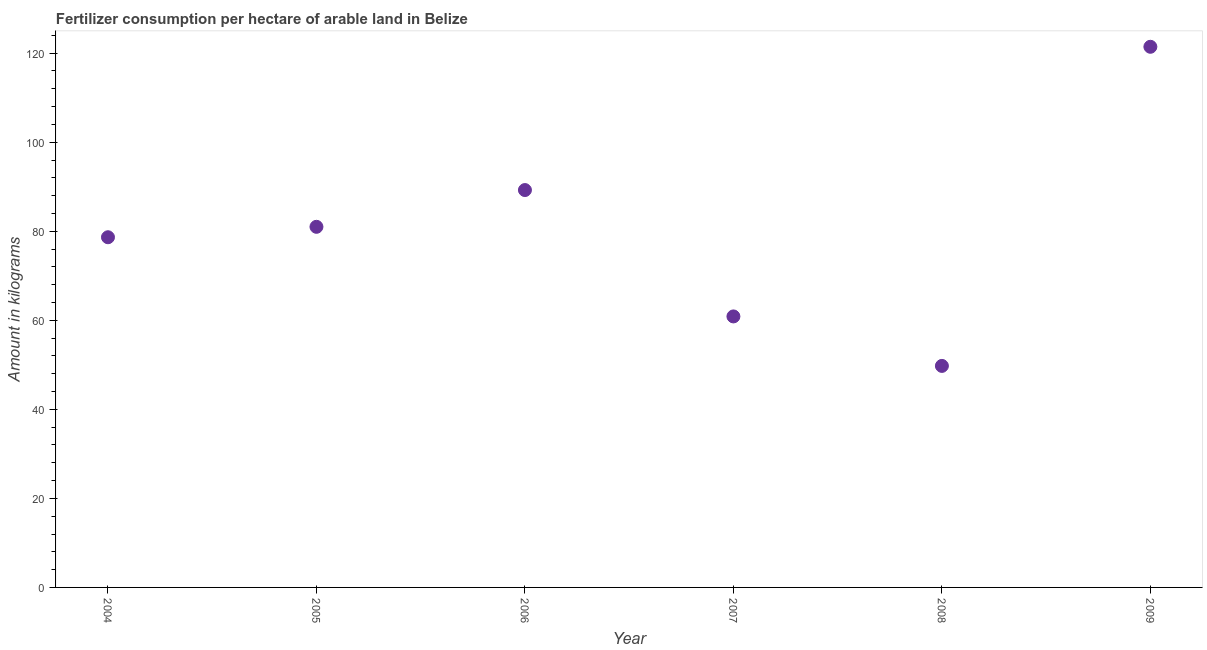What is the amount of fertilizer consumption in 2004?
Offer a terse response. 78.66. Across all years, what is the maximum amount of fertilizer consumption?
Make the answer very short. 121.44. Across all years, what is the minimum amount of fertilizer consumption?
Offer a very short reply. 49.76. What is the sum of the amount of fertilizer consumption?
Offer a terse response. 480.98. What is the difference between the amount of fertilizer consumption in 2006 and 2008?
Provide a short and direct response. 39.5. What is the average amount of fertilizer consumption per year?
Your response must be concise. 80.16. What is the median amount of fertilizer consumption?
Offer a very short reply. 79.83. In how many years, is the amount of fertilizer consumption greater than 60 kg?
Ensure brevity in your answer.  5. Do a majority of the years between 2006 and 2007 (inclusive) have amount of fertilizer consumption greater than 92 kg?
Provide a short and direct response. No. What is the ratio of the amount of fertilizer consumption in 2004 to that in 2008?
Ensure brevity in your answer.  1.58. What is the difference between the highest and the second highest amount of fertilizer consumption?
Keep it short and to the point. 32.18. What is the difference between the highest and the lowest amount of fertilizer consumption?
Give a very brief answer. 71.68. How many years are there in the graph?
Your response must be concise. 6. What is the title of the graph?
Your answer should be very brief. Fertilizer consumption per hectare of arable land in Belize . What is the label or title of the X-axis?
Offer a terse response. Year. What is the label or title of the Y-axis?
Make the answer very short. Amount in kilograms. What is the Amount in kilograms in 2004?
Offer a terse response. 78.66. What is the Amount in kilograms in 2006?
Your answer should be compact. 89.26. What is the Amount in kilograms in 2007?
Provide a succinct answer. 60.87. What is the Amount in kilograms in 2008?
Provide a short and direct response. 49.76. What is the Amount in kilograms in 2009?
Keep it short and to the point. 121.44. What is the difference between the Amount in kilograms in 2004 and 2005?
Your answer should be compact. -2.34. What is the difference between the Amount in kilograms in 2004 and 2006?
Your response must be concise. -10.6. What is the difference between the Amount in kilograms in 2004 and 2007?
Give a very brief answer. 17.79. What is the difference between the Amount in kilograms in 2004 and 2008?
Keep it short and to the point. 28.9. What is the difference between the Amount in kilograms in 2004 and 2009?
Your response must be concise. -42.78. What is the difference between the Amount in kilograms in 2005 and 2006?
Offer a terse response. -8.26. What is the difference between the Amount in kilograms in 2005 and 2007?
Your response must be concise. 20.13. What is the difference between the Amount in kilograms in 2005 and 2008?
Give a very brief answer. 31.24. What is the difference between the Amount in kilograms in 2005 and 2009?
Keep it short and to the point. -40.44. What is the difference between the Amount in kilograms in 2006 and 2007?
Provide a succinct answer. 28.39. What is the difference between the Amount in kilograms in 2006 and 2008?
Ensure brevity in your answer.  39.5. What is the difference between the Amount in kilograms in 2006 and 2009?
Make the answer very short. -32.18. What is the difference between the Amount in kilograms in 2007 and 2008?
Give a very brief answer. 11.11. What is the difference between the Amount in kilograms in 2007 and 2009?
Provide a short and direct response. -60.57. What is the difference between the Amount in kilograms in 2008 and 2009?
Provide a succinct answer. -71.68. What is the ratio of the Amount in kilograms in 2004 to that in 2006?
Ensure brevity in your answer.  0.88. What is the ratio of the Amount in kilograms in 2004 to that in 2007?
Give a very brief answer. 1.29. What is the ratio of the Amount in kilograms in 2004 to that in 2008?
Offer a terse response. 1.58. What is the ratio of the Amount in kilograms in 2004 to that in 2009?
Your answer should be compact. 0.65. What is the ratio of the Amount in kilograms in 2005 to that in 2006?
Your response must be concise. 0.91. What is the ratio of the Amount in kilograms in 2005 to that in 2007?
Your response must be concise. 1.33. What is the ratio of the Amount in kilograms in 2005 to that in 2008?
Your response must be concise. 1.63. What is the ratio of the Amount in kilograms in 2005 to that in 2009?
Give a very brief answer. 0.67. What is the ratio of the Amount in kilograms in 2006 to that in 2007?
Your answer should be very brief. 1.47. What is the ratio of the Amount in kilograms in 2006 to that in 2008?
Your response must be concise. 1.79. What is the ratio of the Amount in kilograms in 2006 to that in 2009?
Ensure brevity in your answer.  0.73. What is the ratio of the Amount in kilograms in 2007 to that in 2008?
Keep it short and to the point. 1.22. What is the ratio of the Amount in kilograms in 2007 to that in 2009?
Ensure brevity in your answer.  0.5. What is the ratio of the Amount in kilograms in 2008 to that in 2009?
Your answer should be very brief. 0.41. 